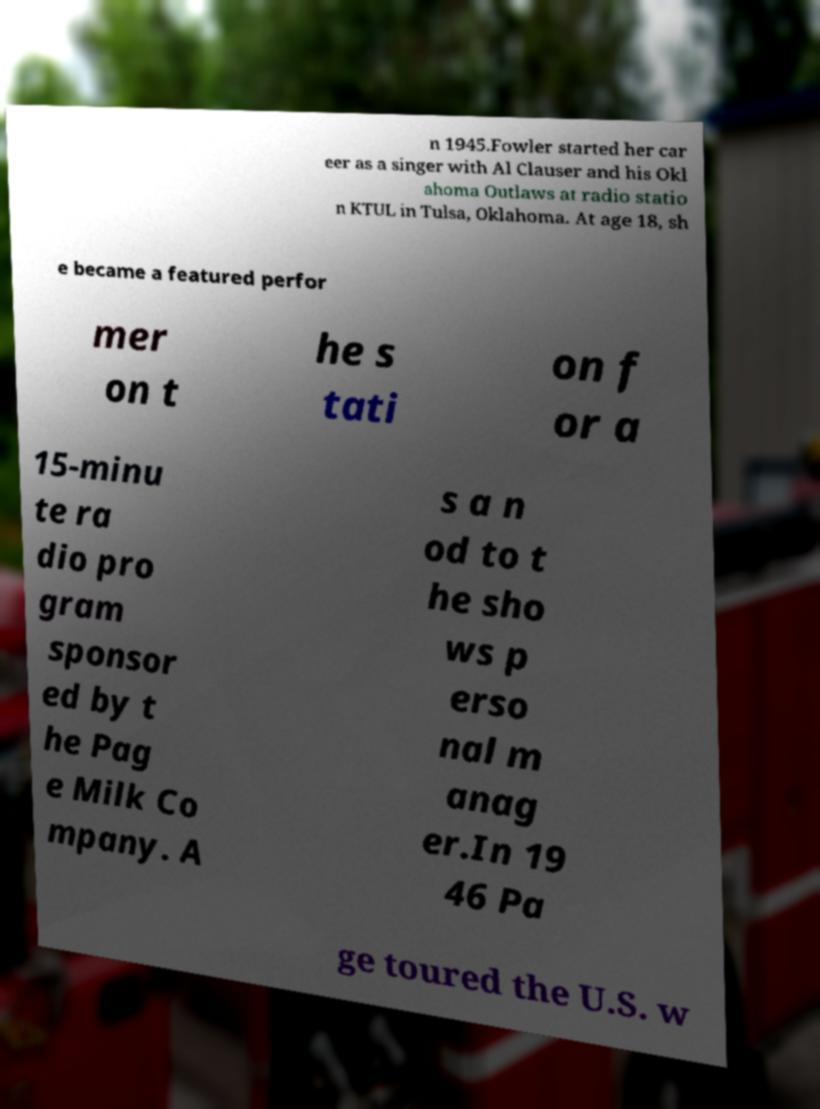Can you read and provide the text displayed in the image?This photo seems to have some interesting text. Can you extract and type it out for me? n 1945.Fowler started her car eer as a singer with Al Clauser and his Okl ahoma Outlaws at radio statio n KTUL in Tulsa, Oklahoma. At age 18, sh e became a featured perfor mer on t he s tati on f or a 15-minu te ra dio pro gram sponsor ed by t he Pag e Milk Co mpany. A s a n od to t he sho ws p erso nal m anag er.In 19 46 Pa ge toured the U.S. w 